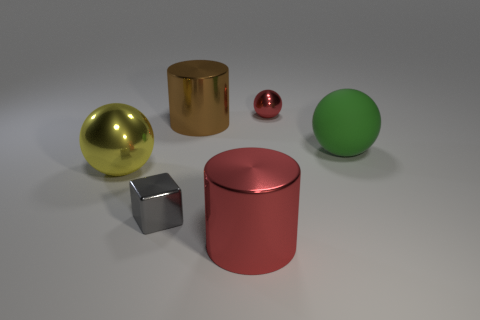Add 4 green objects. How many objects exist? 10 Subtract all cylinders. How many objects are left? 4 Subtract all cyan shiny objects. Subtract all red metallic cylinders. How many objects are left? 5 Add 6 small gray blocks. How many small gray blocks are left? 7 Add 6 big cyan rubber cubes. How many big cyan rubber cubes exist? 6 Subtract 0 brown balls. How many objects are left? 6 